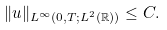Convert formula to latex. <formula><loc_0><loc_0><loc_500><loc_500>\| u \| _ { L ^ { \infty } ( 0 , T ; L ^ { 2 } ( \mathbb { R } ) ) } \leq C .</formula> 